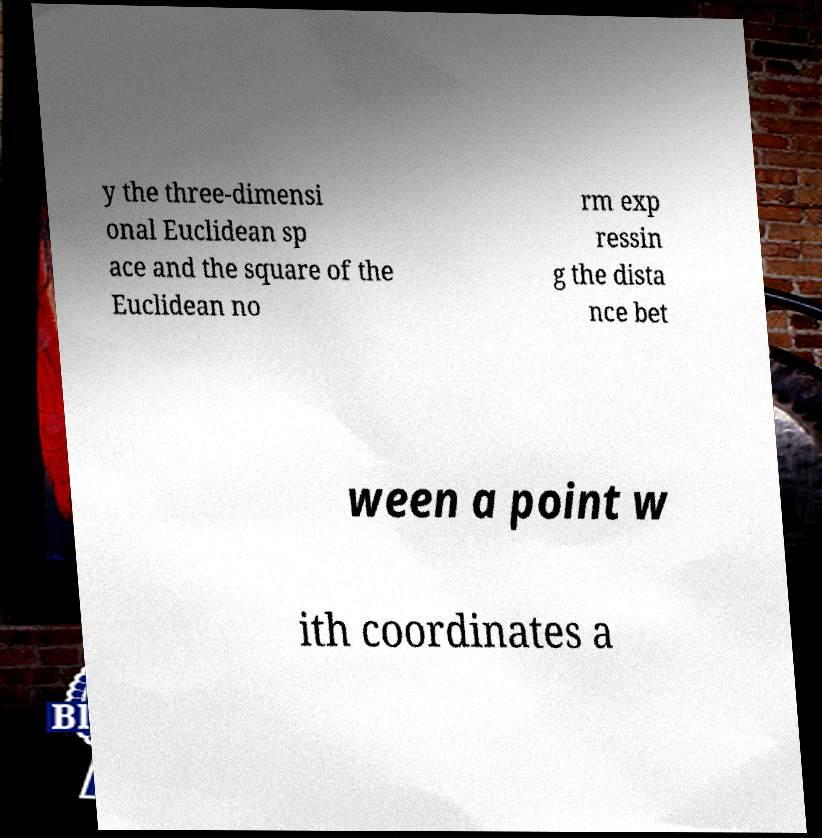There's text embedded in this image that I need extracted. Can you transcribe it verbatim? y the three-dimensi onal Euclidean sp ace and the square of the Euclidean no rm exp ressin g the dista nce bet ween a point w ith coordinates a 